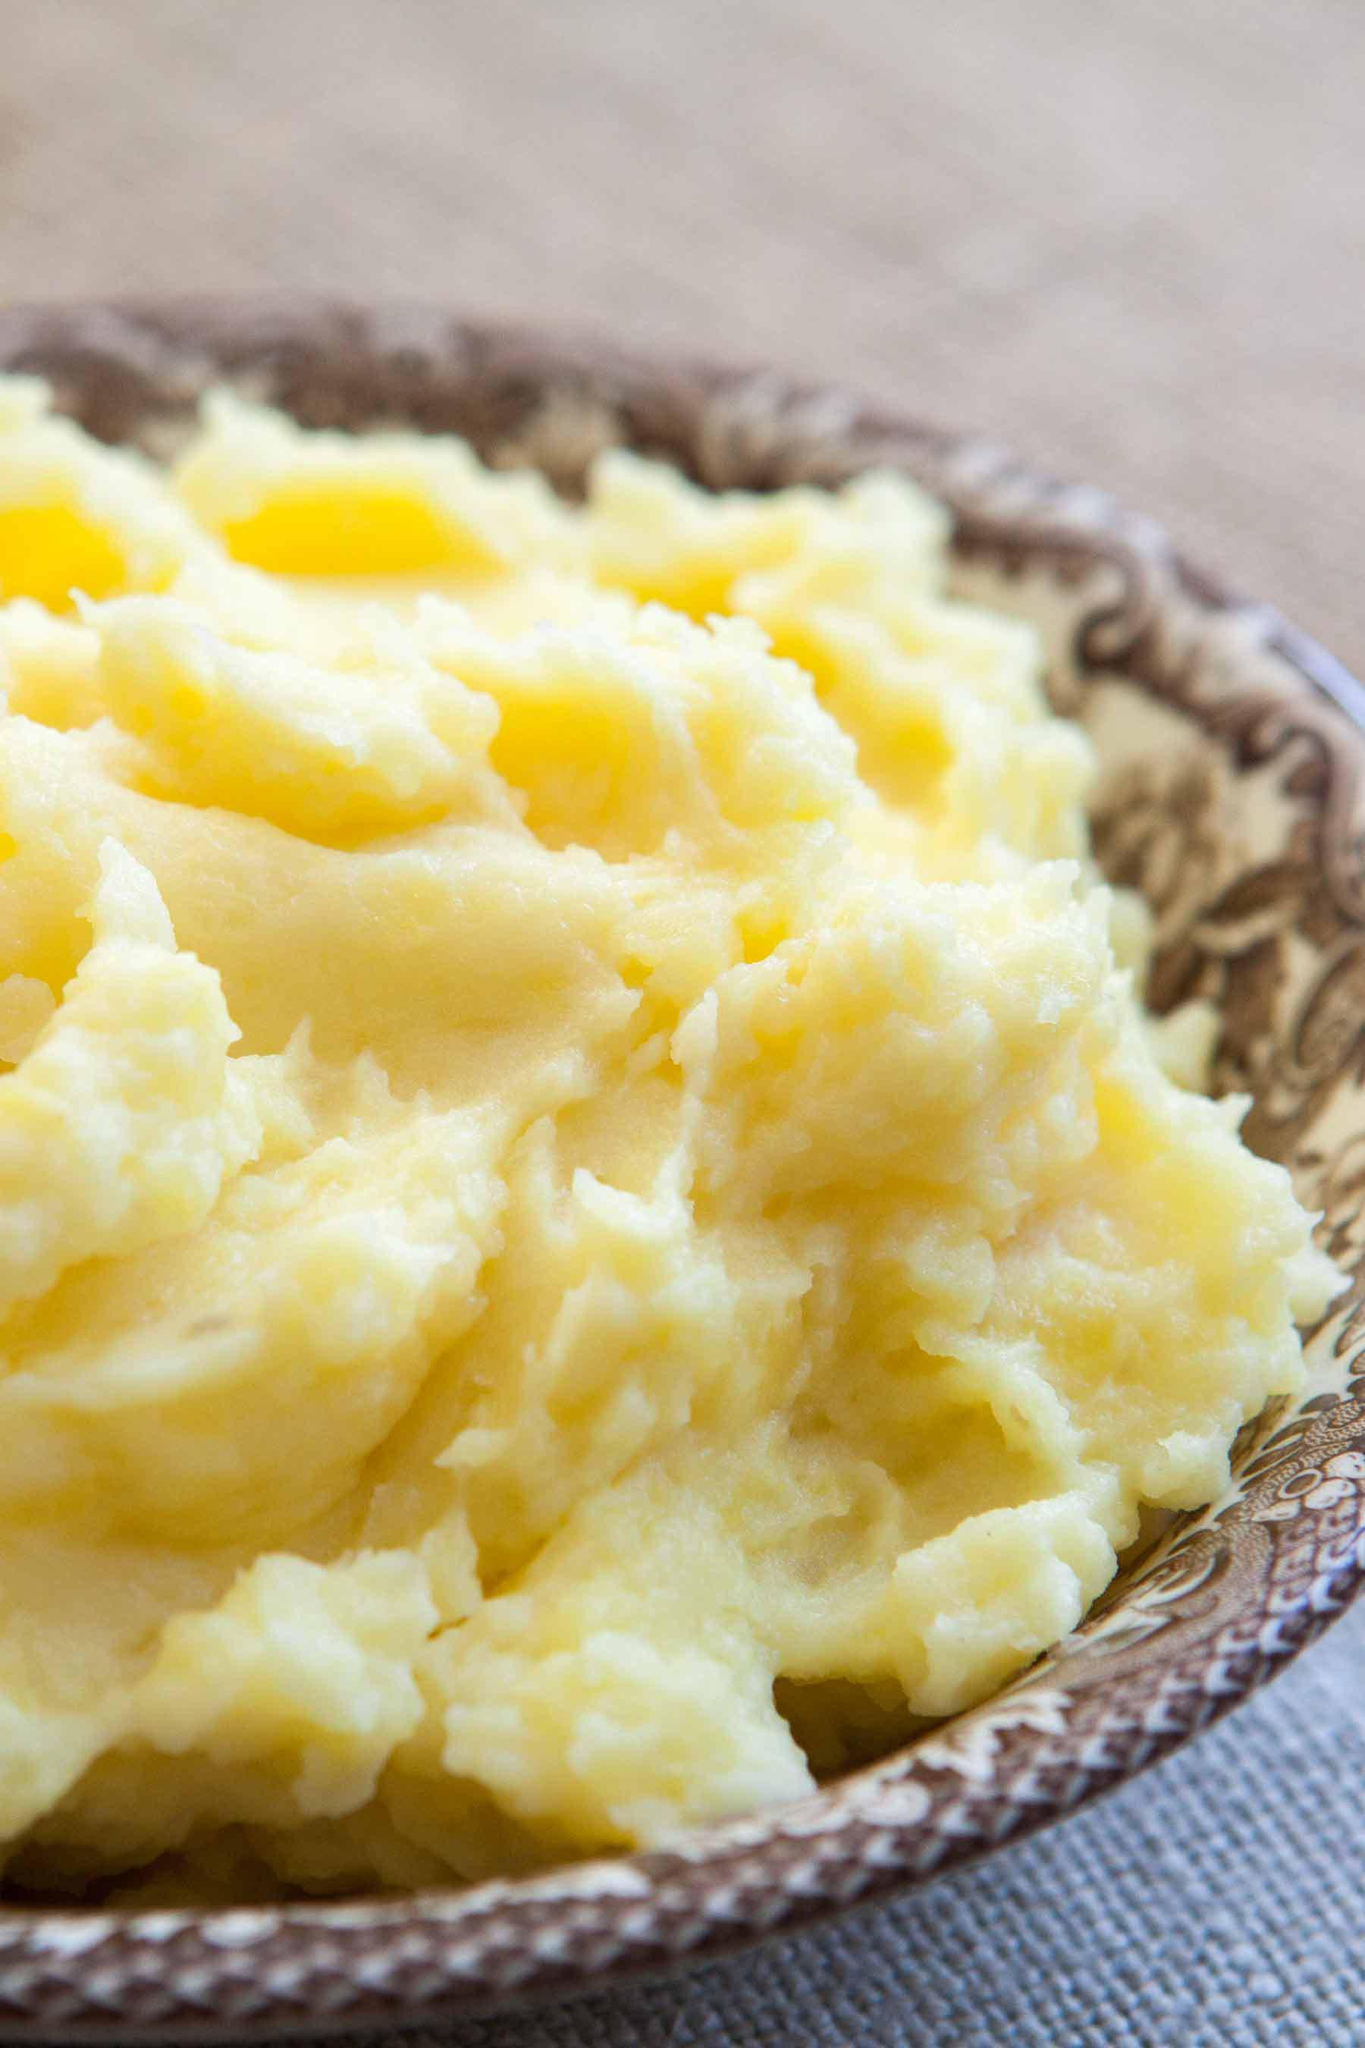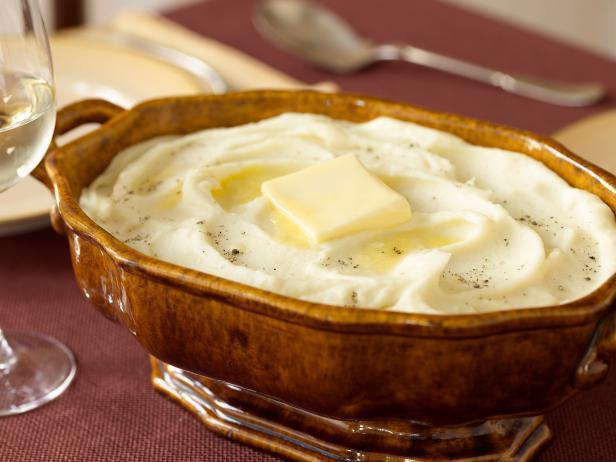The first image is the image on the left, the second image is the image on the right. Examine the images to the left and right. Is the description "Oily butter is melting on at least one of the dishes." accurate? Answer yes or no. Yes. 